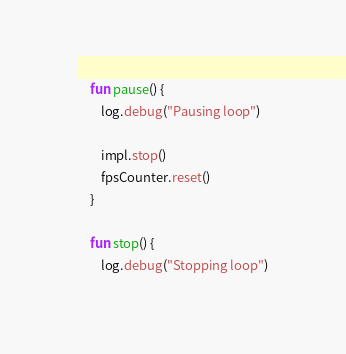<code> <loc_0><loc_0><loc_500><loc_500><_Kotlin_>    fun pause() {
        log.debug("Pausing loop")

        impl.stop()
        fpsCounter.reset()
    }

    fun stop() {
        log.debug("Stopping loop")
</code> 